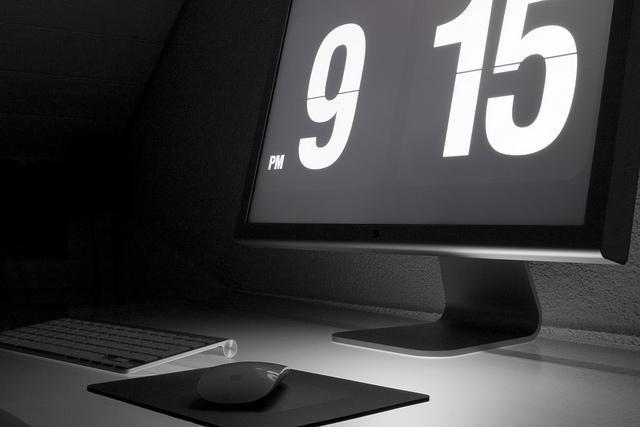How many cars on the road?
Give a very brief answer. 0. 